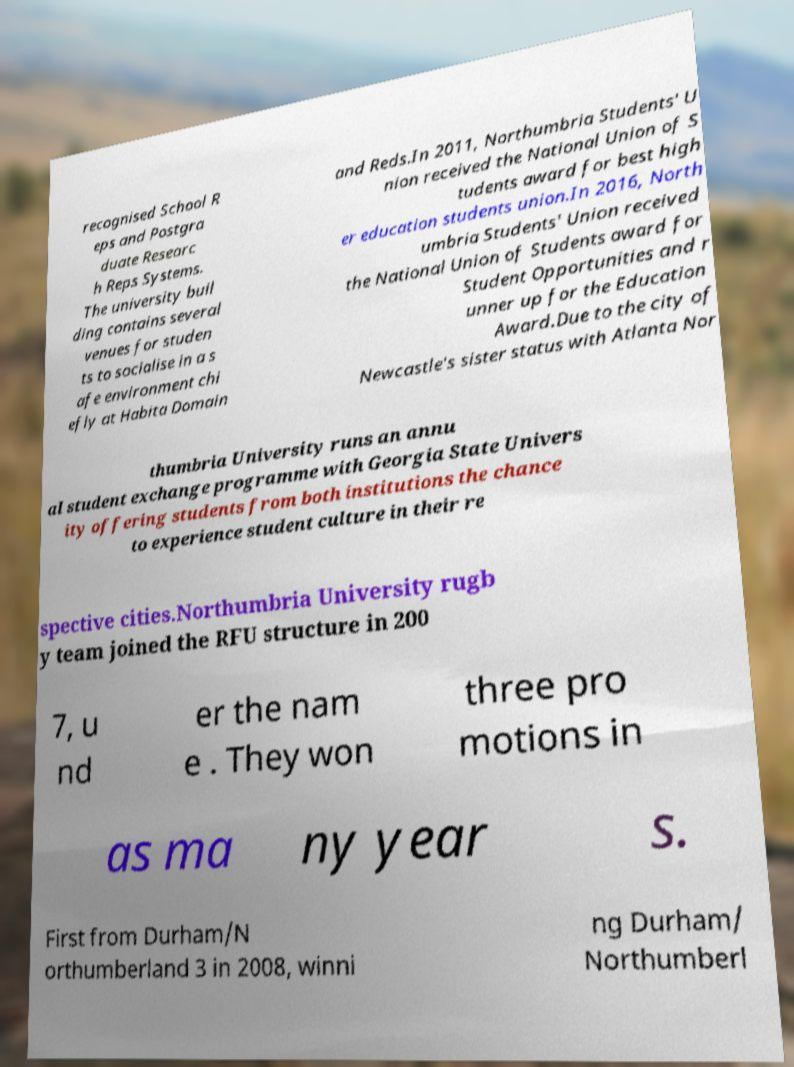I need the written content from this picture converted into text. Can you do that? recognised School R eps and Postgra duate Researc h Reps Systems. The university buil ding contains several venues for studen ts to socialise in a s afe environment chi efly at Habita Domain and Reds.In 2011, Northumbria Students' U nion received the National Union of S tudents award for best high er education students union.In 2016, North umbria Students' Union received the National Union of Students award for Student Opportunities and r unner up for the Education Award.Due to the city of Newcastle's sister status with Atlanta Nor thumbria University runs an annu al student exchange programme with Georgia State Univers ity offering students from both institutions the chance to experience student culture in their re spective cities.Northumbria University rugb y team joined the RFU structure in 200 7, u nd er the nam e . They won three pro motions in as ma ny year s. First from Durham/N orthumberland 3 in 2008, winni ng Durham/ Northumberl 